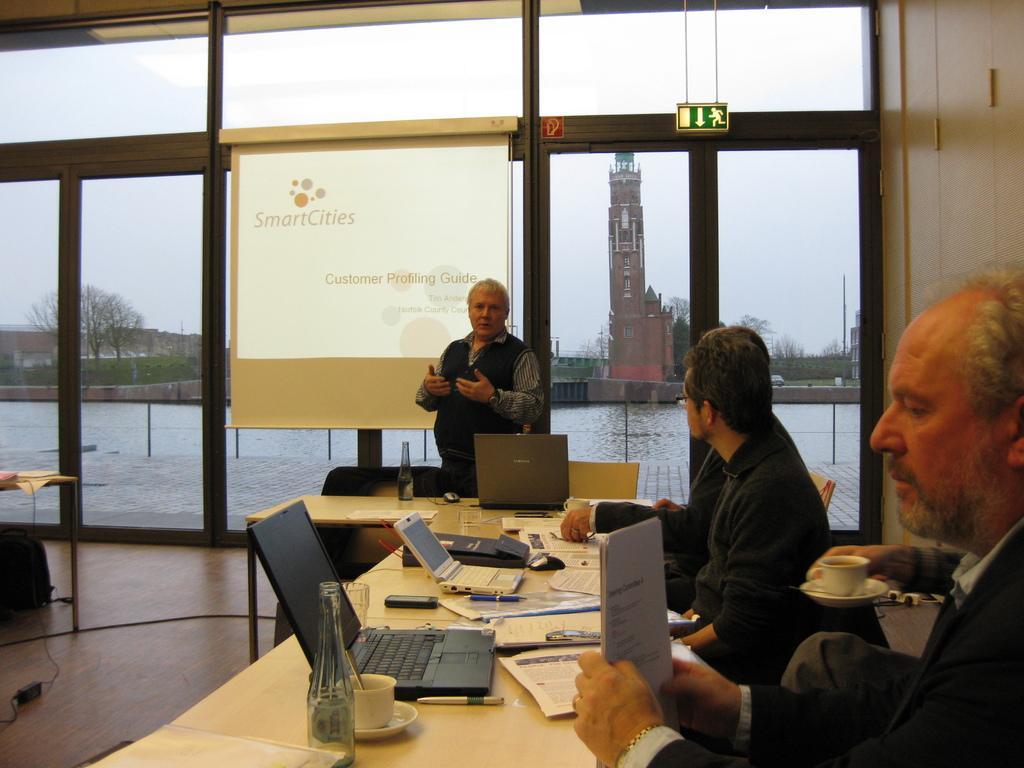Describe this image in one or two sentences. In the picture I can see three men sitting on the chairs and they are on the right side. I can see the hands of a person holding a cup. I can see the tables on the floor. I can see the laptops, papers, a cup, bottles and a mobile phone are kept on the table. There is a man standing on the floor and he is explaining something. I can see the glass windows and screen. In the background, I can see the buildings, trees and water. 